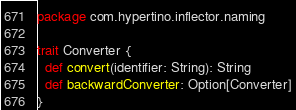<code> <loc_0><loc_0><loc_500><loc_500><_Scala_>package com.hypertino.inflector.naming

trait Converter {
  def convert(identifier: String): String
  def backwardConverter: Option[Converter]
}
</code> 